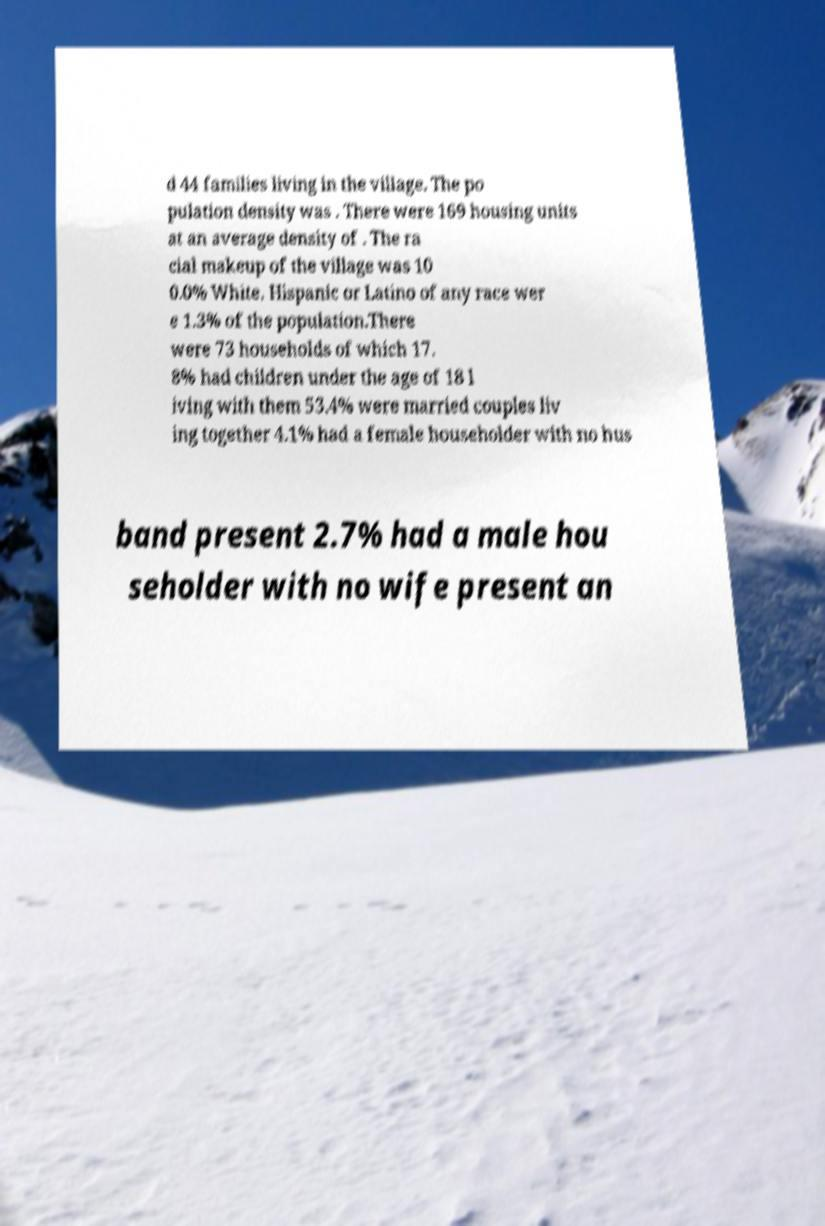I need the written content from this picture converted into text. Can you do that? d 44 families living in the village. The po pulation density was . There were 169 housing units at an average density of . The ra cial makeup of the village was 10 0.0% White. Hispanic or Latino of any race wer e 1.3% of the population.There were 73 households of which 17. 8% had children under the age of 18 l iving with them 53.4% were married couples liv ing together 4.1% had a female householder with no hus band present 2.7% had a male hou seholder with no wife present an 